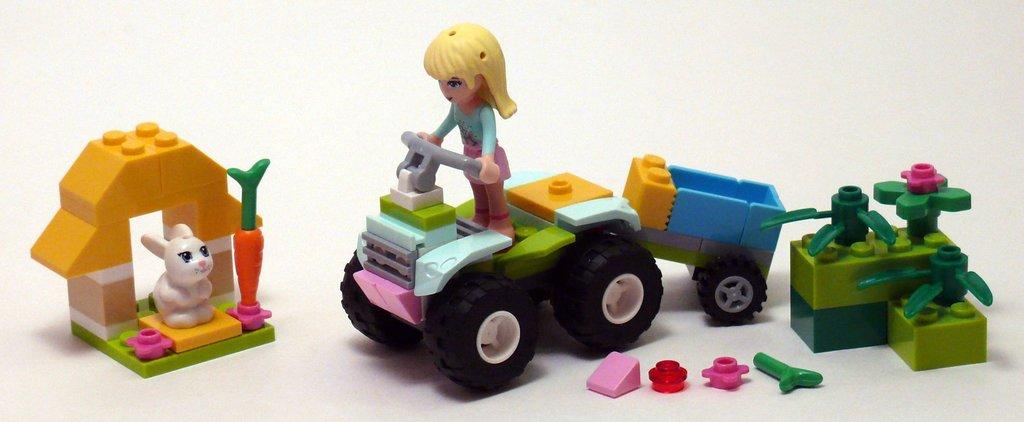What type of toy is in the shape of a rabbit in the image? There is a toy in the shape of a rabbit in the image. What other toy is in the shape of a vegetable in the image? There is a toy in the shape of a carrot in the image. What type of toy is in the shape of a human figure in the image? There is a toy in the shape of a doll in the image. What type of toy is in the shape of a vehicle in the image? There is a toy in the shape of a vehicle in the image. Can you describe any other toys present in the image? There are other toys in the image, but their specific shapes are not mentioned in the provided facts. What type of prose is being recited by the toys in the image? There is no indication in the image that the toys are reciting any prose or engaging in any form of communication. 